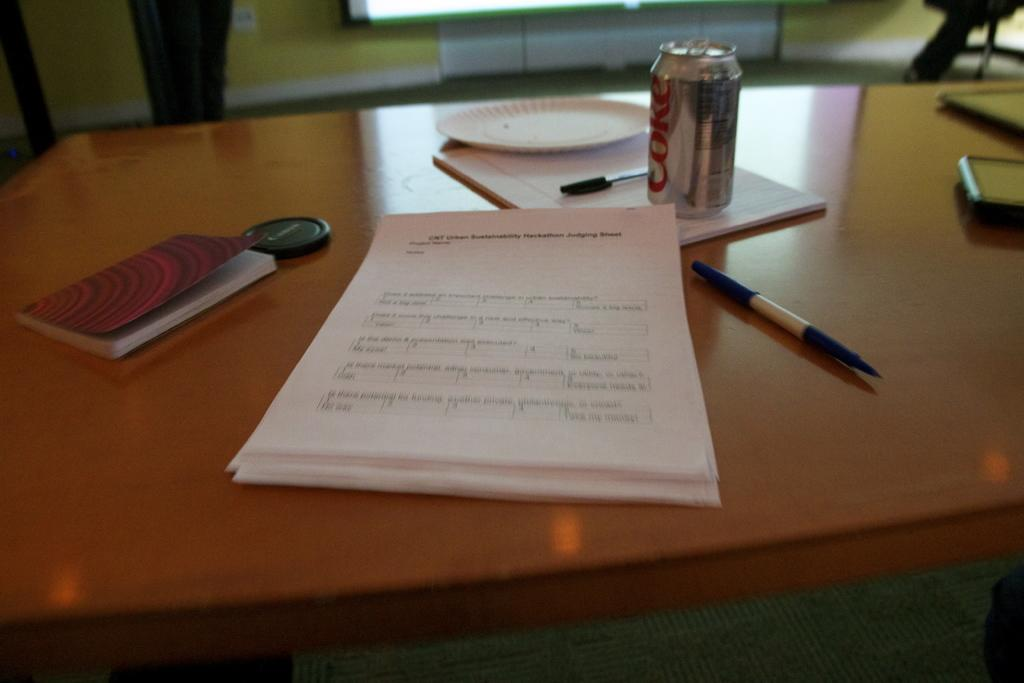What can be seen on the table in the image? There are many objects placed on the table in the image. What is located at the top of the image? There is a projector screen at the top of the image. How does the taste of the objects on the table affect the bushes in the image? There are no bushes present in the image, and the taste of the objects on the table does not affect any bushes. 